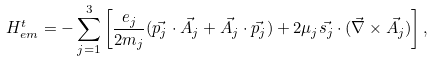Convert formula to latex. <formula><loc_0><loc_0><loc_500><loc_500>H ^ { t } _ { e m } = - \sum _ { j = 1 } ^ { 3 } \left [ \frac { e _ { j } } { 2 m _ { j } } ( \vec { p _ { j } } \cdot \vec { A _ { j } } + \vec { A _ { j } } \cdot \vec { p _ { j } } ) + 2 \mu _ { j } \vec { s _ { j } } \cdot ( \vec { \nabla } \times \vec { A _ { j } } ) \right ] ,</formula> 